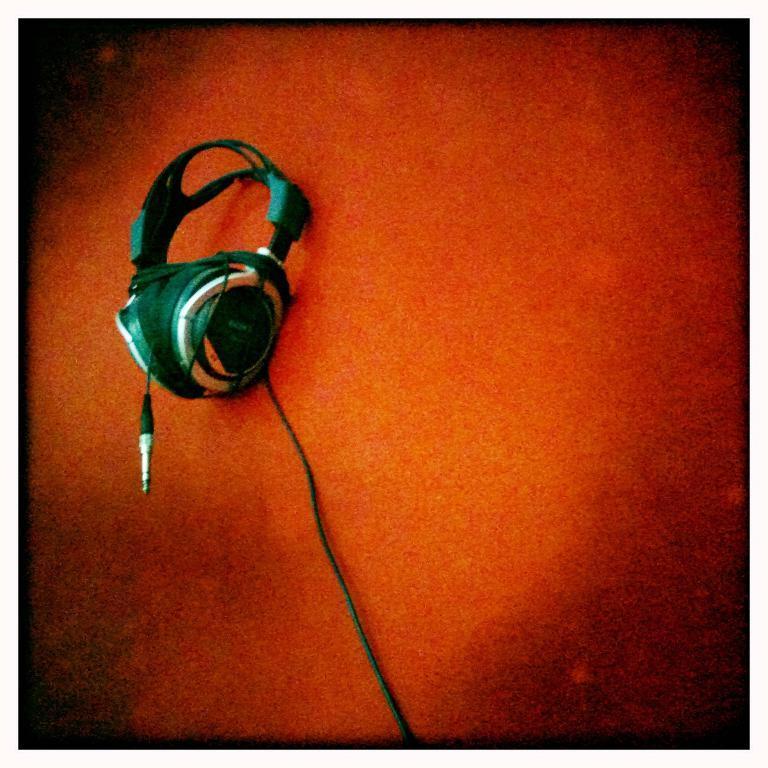Describe this image in one or two sentences. In this image at the bottom there is a floor, and in the foreground there is a headset. 